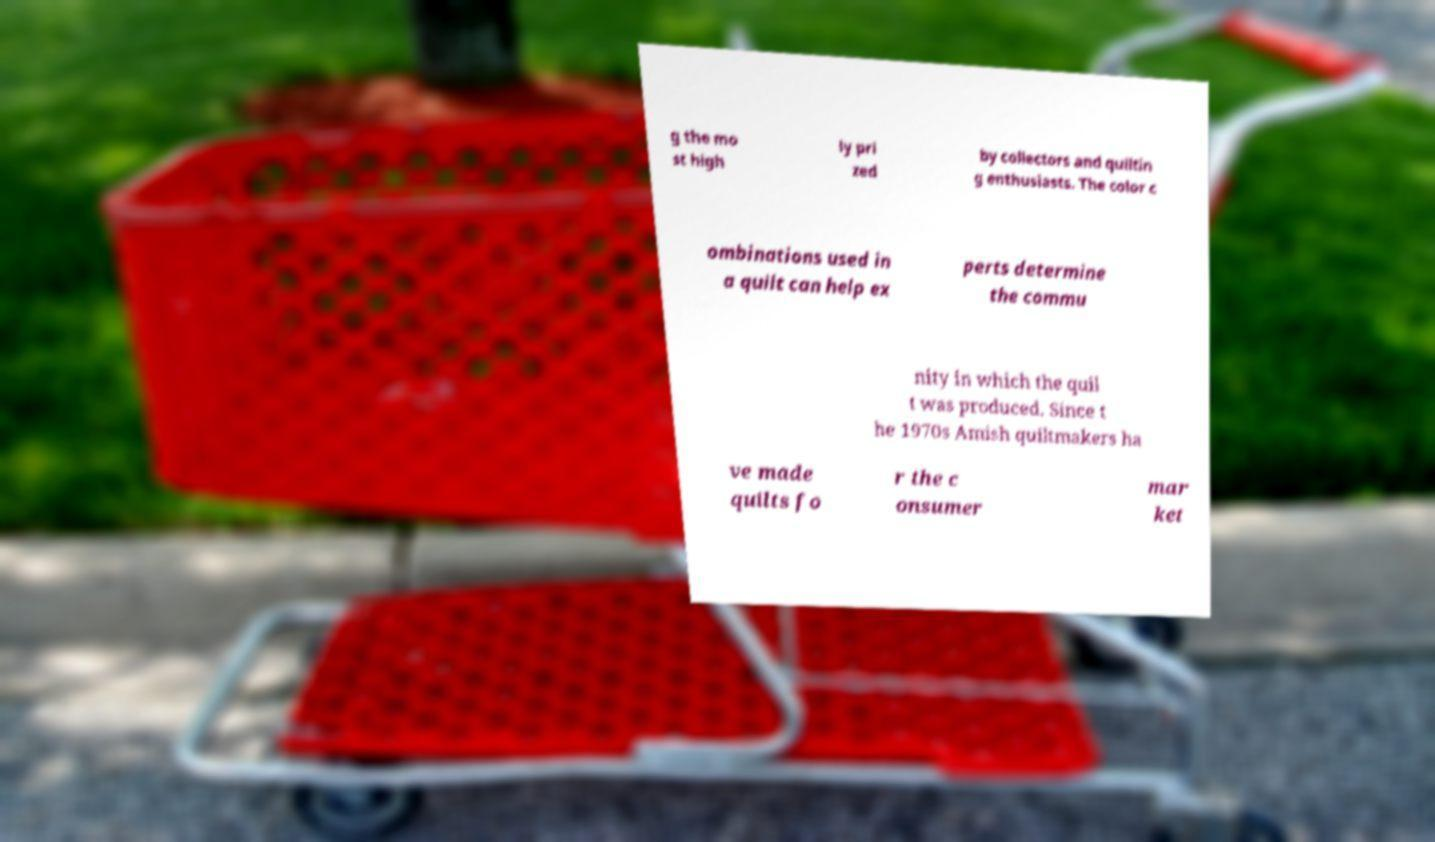Could you assist in decoding the text presented in this image and type it out clearly? g the mo st high ly pri zed by collectors and quiltin g enthusiasts. The color c ombinations used in a quilt can help ex perts determine the commu nity in which the quil t was produced. Since t he 1970s Amish quiltmakers ha ve made quilts fo r the c onsumer mar ket 